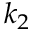Convert formula to latex. <formula><loc_0><loc_0><loc_500><loc_500>k _ { 2 }</formula> 